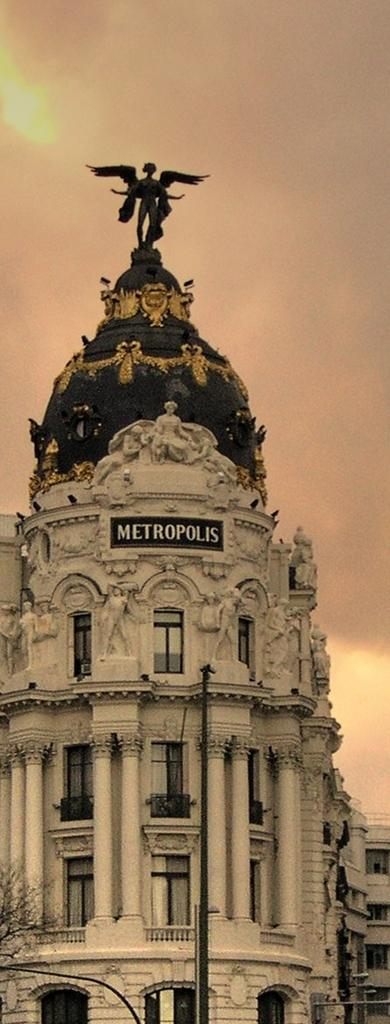What type of structures can be seen in the image? There are street lights and buildings visible in the image. What natural element is present in the image? There is a tree in the image. What can be seen in the background of the image? The sky is visible in the background of the image. Are there any buildings in the foreground of the image? No, the buildings are in the background of the image. What type of teaching method is being demonstrated in the image? There is no teaching or educational activity depicted in the image. Can you see a kitten playing with the tree in the image? There is no kitten present in the image; it only features a tree, street lights, buildings, and the sky. 